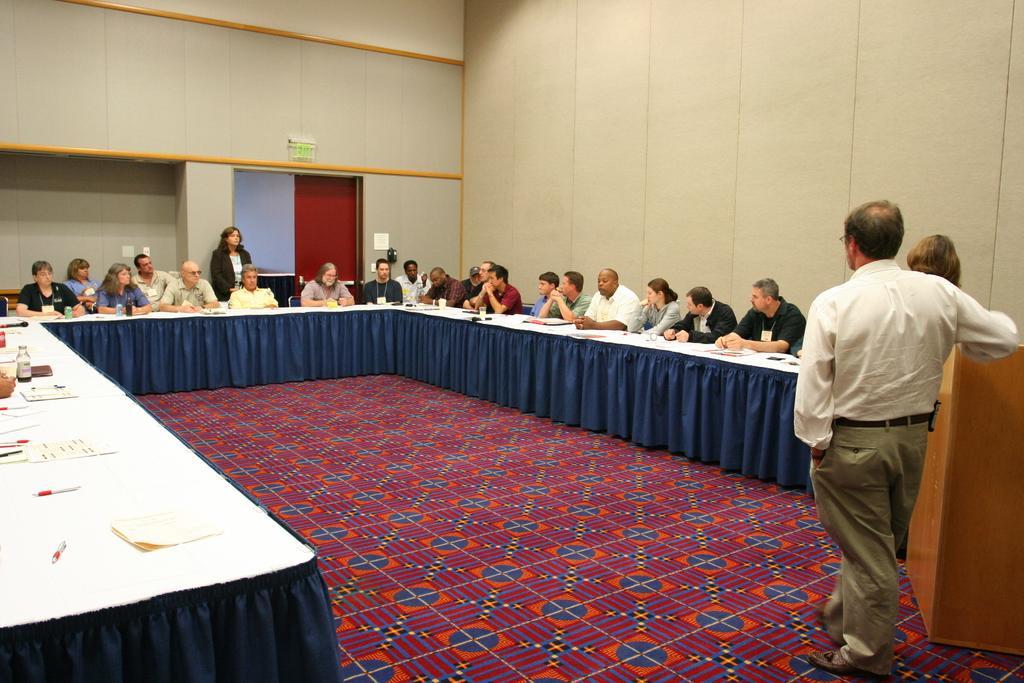Describe this image in one or two sentences. In this picture I can see three persons standing, there are group of people sitting, there are papers, pens and some other objects on the tables, there is a podium, and in the background there is a wall and a door. 